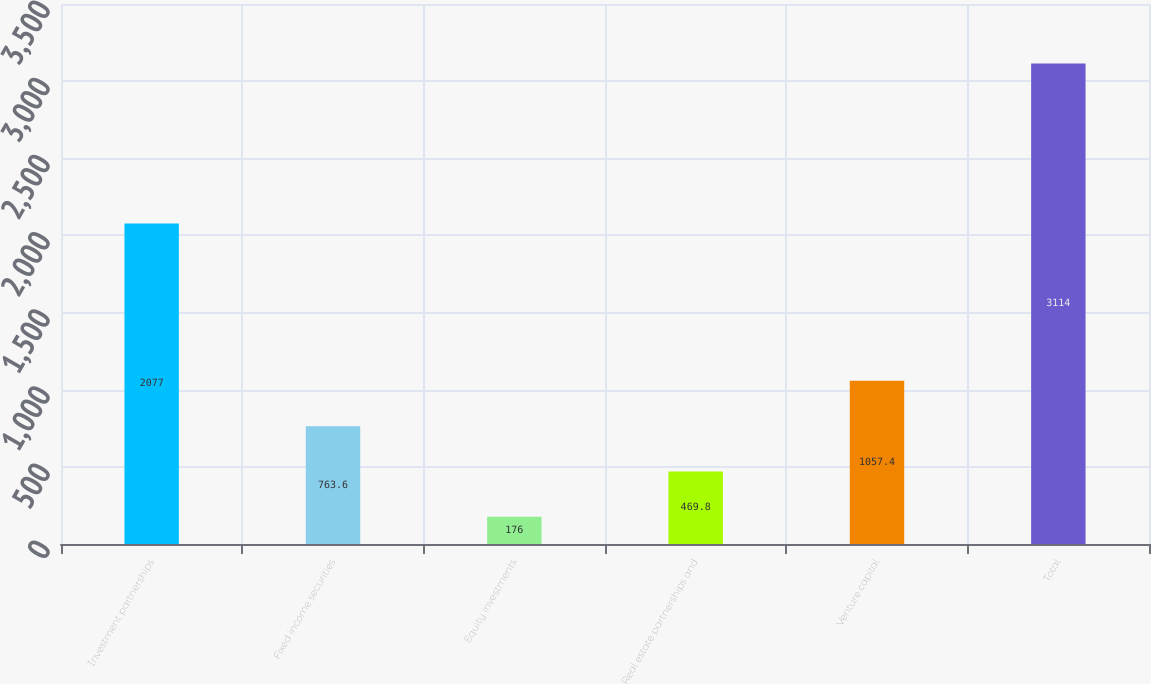<chart> <loc_0><loc_0><loc_500><loc_500><bar_chart><fcel>Investment partnerships<fcel>Fixed income securities<fcel>Equity investments<fcel>Real estate partnerships and<fcel>Venture capital<fcel>Total<nl><fcel>2077<fcel>763.6<fcel>176<fcel>469.8<fcel>1057.4<fcel>3114<nl></chart> 